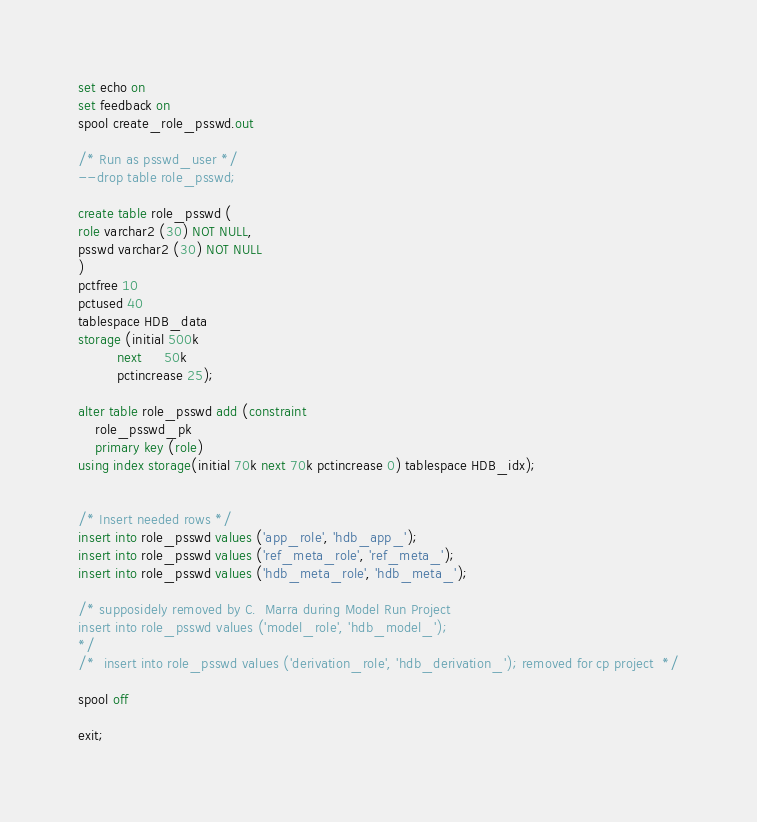Convert code to text. <code><loc_0><loc_0><loc_500><loc_500><_SQL_>set echo on
set feedback on
spool create_role_psswd.out

/* Run as psswd_user */
--drop table role_psswd;

create table role_psswd (
role varchar2 (30) NOT NULL,
psswd varchar2 (30) NOT NULL
)
pctfree 10
pctused 40
tablespace HDB_data
storage (initial 500k
         next     50k
         pctincrease 25);

alter table role_psswd add (constraint
    role_psswd_pk
    primary key (role)
using index storage(initial 70k next 70k pctincrease 0) tablespace HDB_idx);
	

/* Insert needed rows */
insert into role_psswd values ('app_role', 'hdb_app_');
insert into role_psswd values ('ref_meta_role', 'ref_meta_');
insert into role_psswd values ('hdb_meta_role', 'hdb_meta_');

/* supposidely removed by C.  Marra during Model Run Project
insert into role_psswd values ('model_role', 'hdb_model_');
*/
/*  insert into role_psswd values ('derivation_role', 'hdb_derivation_'); removed for cp project  */

spool off

exit;

</code> 